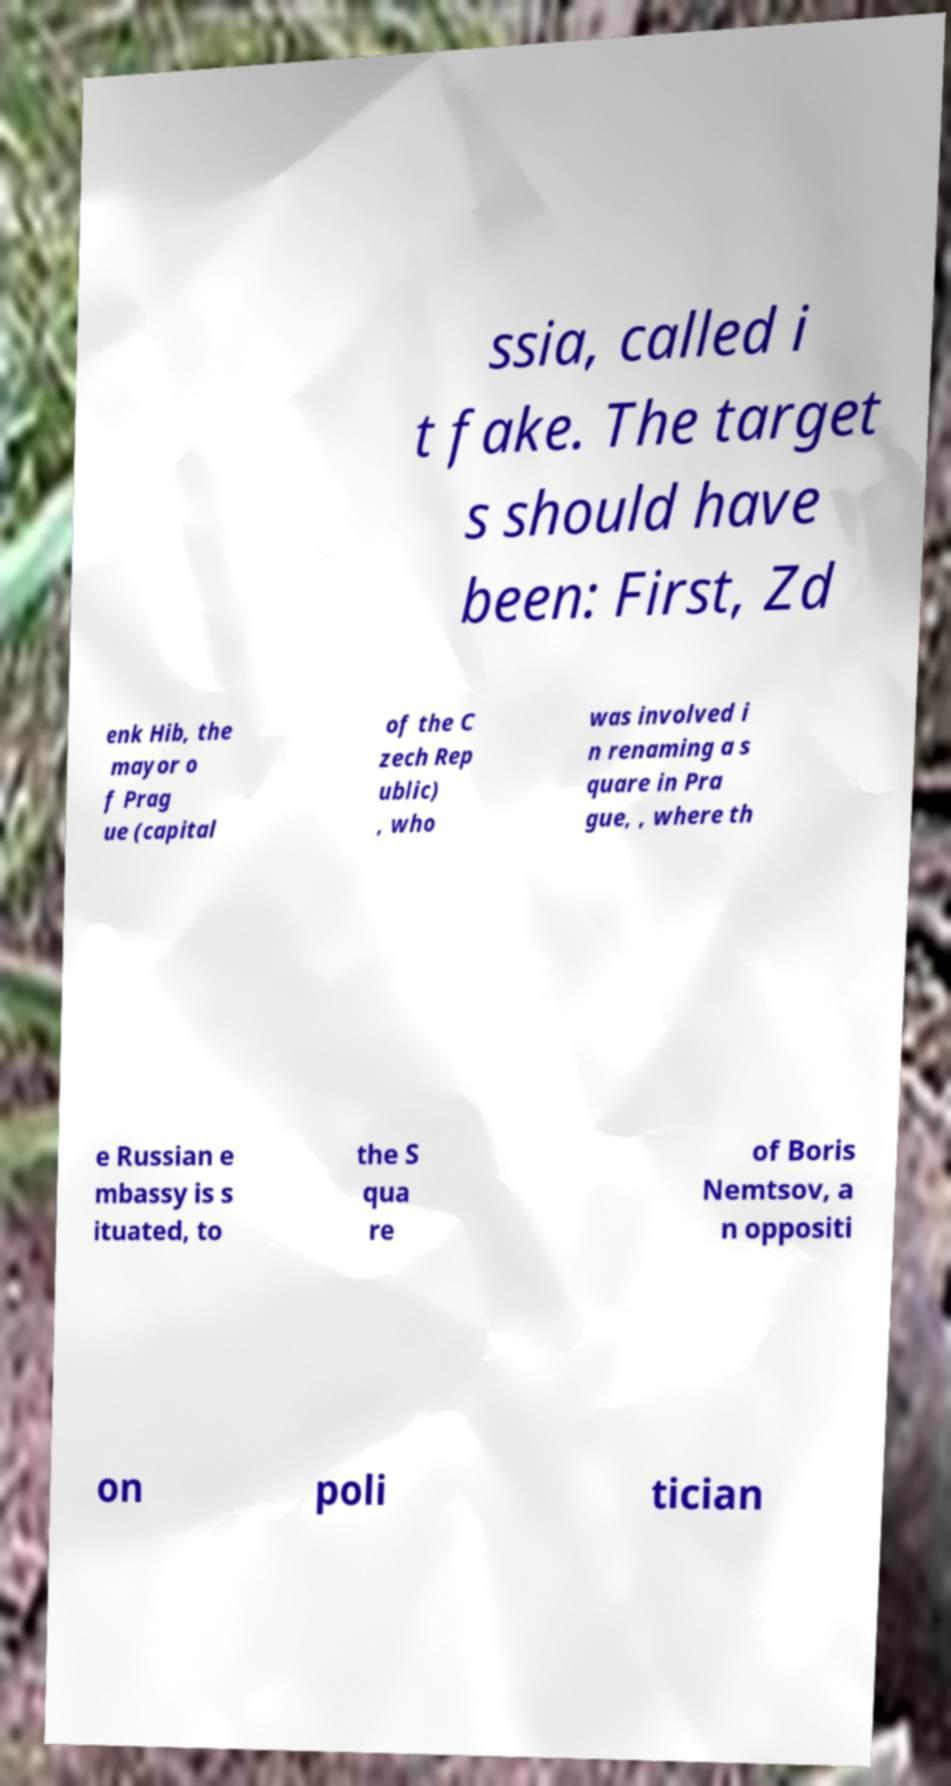For documentation purposes, I need the text within this image transcribed. Could you provide that? ssia, called i t fake. The target s should have been: First, Zd enk Hib, the mayor o f Prag ue (capital of the C zech Rep ublic) , who was involved i n renaming a s quare in Pra gue, , where th e Russian e mbassy is s ituated, to the S qua re of Boris Nemtsov, a n oppositi on poli tician 